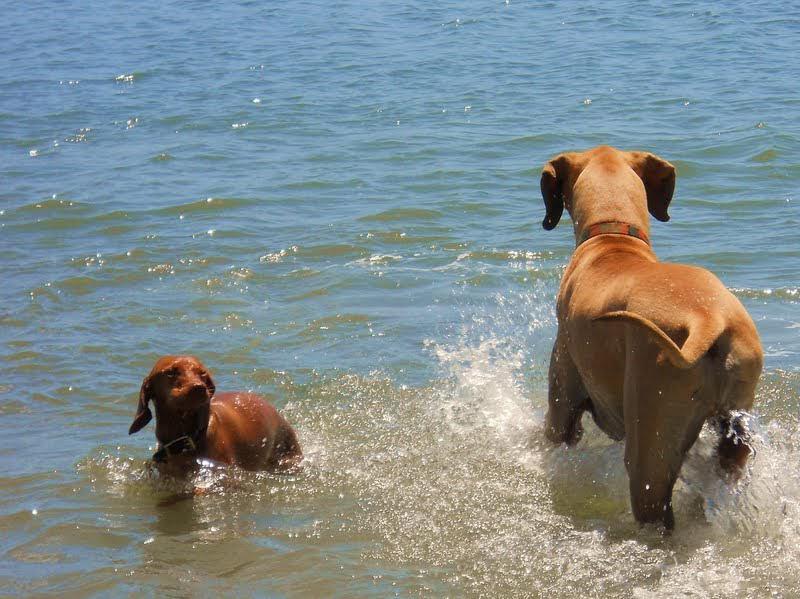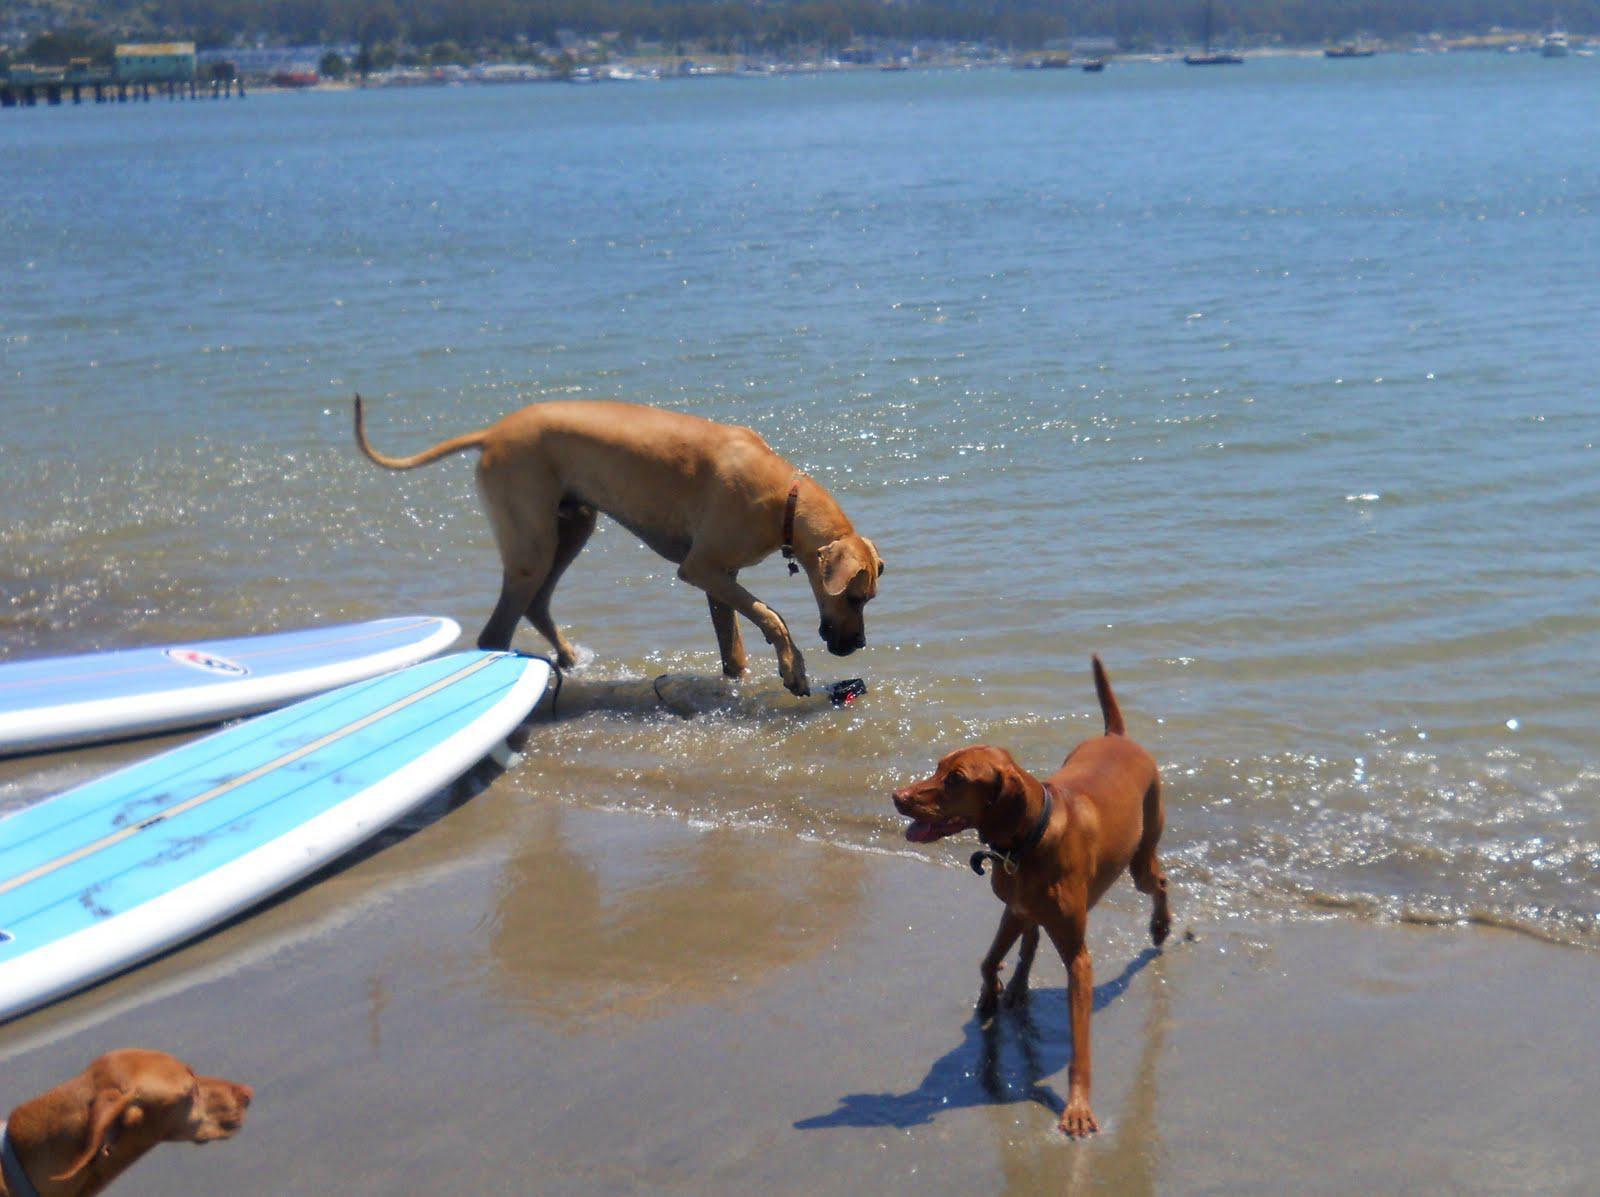The first image is the image on the left, the second image is the image on the right. Evaluate the accuracy of this statement regarding the images: "There are three dogs in the image pair.". Is it true? Answer yes or no. No. 